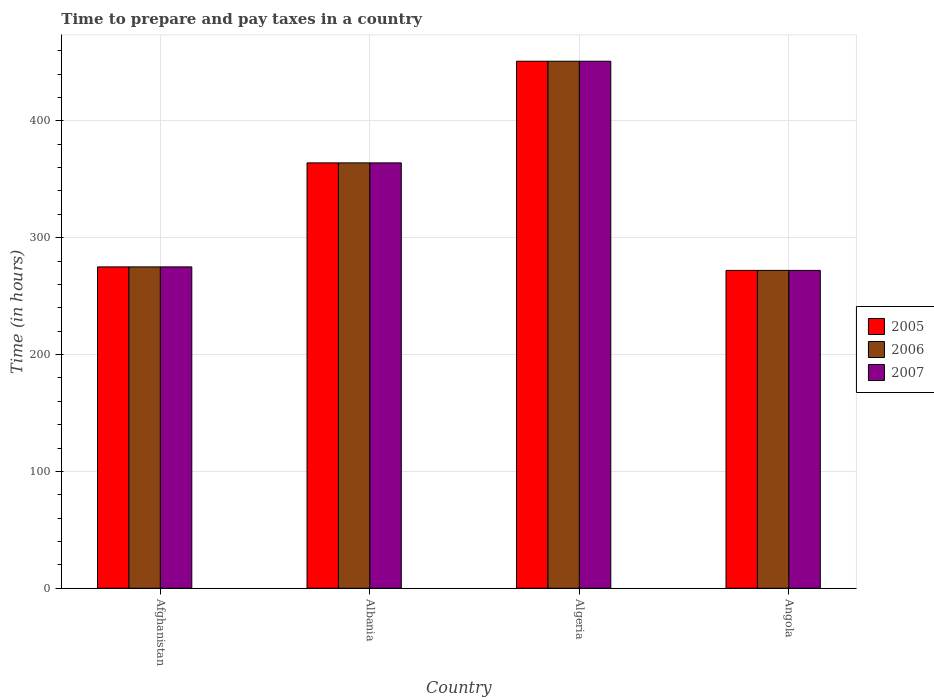How many groups of bars are there?
Ensure brevity in your answer.  4. Are the number of bars on each tick of the X-axis equal?
Offer a very short reply. Yes. How many bars are there on the 1st tick from the right?
Provide a succinct answer. 3. What is the label of the 3rd group of bars from the left?
Keep it short and to the point. Algeria. In how many cases, is the number of bars for a given country not equal to the number of legend labels?
Your answer should be very brief. 0. What is the number of hours required to prepare and pay taxes in 2007 in Albania?
Your response must be concise. 364. Across all countries, what is the maximum number of hours required to prepare and pay taxes in 2005?
Provide a succinct answer. 451. Across all countries, what is the minimum number of hours required to prepare and pay taxes in 2006?
Provide a short and direct response. 272. In which country was the number of hours required to prepare and pay taxes in 2006 maximum?
Offer a very short reply. Algeria. In which country was the number of hours required to prepare and pay taxes in 2007 minimum?
Make the answer very short. Angola. What is the total number of hours required to prepare and pay taxes in 2006 in the graph?
Provide a succinct answer. 1362. What is the difference between the number of hours required to prepare and pay taxes in 2006 in Albania and that in Angola?
Provide a short and direct response. 92. What is the difference between the number of hours required to prepare and pay taxes in 2007 in Angola and the number of hours required to prepare and pay taxes in 2005 in Albania?
Keep it short and to the point. -92. What is the average number of hours required to prepare and pay taxes in 2006 per country?
Your answer should be compact. 340.5. In how many countries, is the number of hours required to prepare and pay taxes in 2007 greater than 440 hours?
Keep it short and to the point. 1. What is the ratio of the number of hours required to prepare and pay taxes in 2006 in Albania to that in Angola?
Your answer should be very brief. 1.34. Is the difference between the number of hours required to prepare and pay taxes in 2007 in Afghanistan and Angola greater than the difference between the number of hours required to prepare and pay taxes in 2006 in Afghanistan and Angola?
Give a very brief answer. No. What is the difference between the highest and the second highest number of hours required to prepare and pay taxes in 2005?
Offer a terse response. -176. What is the difference between the highest and the lowest number of hours required to prepare and pay taxes in 2007?
Your answer should be very brief. 179. Is the sum of the number of hours required to prepare and pay taxes in 2005 in Afghanistan and Albania greater than the maximum number of hours required to prepare and pay taxes in 2007 across all countries?
Ensure brevity in your answer.  Yes. How many bars are there?
Offer a very short reply. 12. Are all the bars in the graph horizontal?
Keep it short and to the point. No. Are the values on the major ticks of Y-axis written in scientific E-notation?
Give a very brief answer. No. How many legend labels are there?
Your response must be concise. 3. What is the title of the graph?
Your answer should be very brief. Time to prepare and pay taxes in a country. Does "1991" appear as one of the legend labels in the graph?
Give a very brief answer. No. What is the label or title of the Y-axis?
Ensure brevity in your answer.  Time (in hours). What is the Time (in hours) in 2005 in Afghanistan?
Give a very brief answer. 275. What is the Time (in hours) of 2006 in Afghanistan?
Keep it short and to the point. 275. What is the Time (in hours) of 2007 in Afghanistan?
Your response must be concise. 275. What is the Time (in hours) of 2005 in Albania?
Your response must be concise. 364. What is the Time (in hours) in 2006 in Albania?
Keep it short and to the point. 364. What is the Time (in hours) of 2007 in Albania?
Provide a succinct answer. 364. What is the Time (in hours) in 2005 in Algeria?
Keep it short and to the point. 451. What is the Time (in hours) of 2006 in Algeria?
Your answer should be very brief. 451. What is the Time (in hours) in 2007 in Algeria?
Your answer should be compact. 451. What is the Time (in hours) in 2005 in Angola?
Give a very brief answer. 272. What is the Time (in hours) in 2006 in Angola?
Provide a short and direct response. 272. What is the Time (in hours) in 2007 in Angola?
Your answer should be compact. 272. Across all countries, what is the maximum Time (in hours) of 2005?
Provide a short and direct response. 451. Across all countries, what is the maximum Time (in hours) in 2006?
Provide a succinct answer. 451. Across all countries, what is the maximum Time (in hours) of 2007?
Provide a succinct answer. 451. Across all countries, what is the minimum Time (in hours) of 2005?
Offer a terse response. 272. Across all countries, what is the minimum Time (in hours) in 2006?
Ensure brevity in your answer.  272. Across all countries, what is the minimum Time (in hours) of 2007?
Keep it short and to the point. 272. What is the total Time (in hours) of 2005 in the graph?
Offer a terse response. 1362. What is the total Time (in hours) in 2006 in the graph?
Ensure brevity in your answer.  1362. What is the total Time (in hours) in 2007 in the graph?
Ensure brevity in your answer.  1362. What is the difference between the Time (in hours) of 2005 in Afghanistan and that in Albania?
Provide a succinct answer. -89. What is the difference between the Time (in hours) in 2006 in Afghanistan and that in Albania?
Provide a short and direct response. -89. What is the difference between the Time (in hours) in 2007 in Afghanistan and that in Albania?
Provide a short and direct response. -89. What is the difference between the Time (in hours) in 2005 in Afghanistan and that in Algeria?
Your answer should be compact. -176. What is the difference between the Time (in hours) in 2006 in Afghanistan and that in Algeria?
Provide a succinct answer. -176. What is the difference between the Time (in hours) of 2007 in Afghanistan and that in Algeria?
Keep it short and to the point. -176. What is the difference between the Time (in hours) of 2006 in Afghanistan and that in Angola?
Offer a very short reply. 3. What is the difference between the Time (in hours) of 2005 in Albania and that in Algeria?
Make the answer very short. -87. What is the difference between the Time (in hours) in 2006 in Albania and that in Algeria?
Ensure brevity in your answer.  -87. What is the difference between the Time (in hours) of 2007 in Albania and that in Algeria?
Your response must be concise. -87. What is the difference between the Time (in hours) in 2005 in Albania and that in Angola?
Offer a very short reply. 92. What is the difference between the Time (in hours) of 2006 in Albania and that in Angola?
Give a very brief answer. 92. What is the difference between the Time (in hours) of 2007 in Albania and that in Angola?
Your answer should be very brief. 92. What is the difference between the Time (in hours) of 2005 in Algeria and that in Angola?
Provide a succinct answer. 179. What is the difference between the Time (in hours) in 2006 in Algeria and that in Angola?
Ensure brevity in your answer.  179. What is the difference between the Time (in hours) in 2007 in Algeria and that in Angola?
Provide a succinct answer. 179. What is the difference between the Time (in hours) of 2005 in Afghanistan and the Time (in hours) of 2006 in Albania?
Keep it short and to the point. -89. What is the difference between the Time (in hours) in 2005 in Afghanistan and the Time (in hours) in 2007 in Albania?
Your response must be concise. -89. What is the difference between the Time (in hours) in 2006 in Afghanistan and the Time (in hours) in 2007 in Albania?
Provide a succinct answer. -89. What is the difference between the Time (in hours) of 2005 in Afghanistan and the Time (in hours) of 2006 in Algeria?
Ensure brevity in your answer.  -176. What is the difference between the Time (in hours) in 2005 in Afghanistan and the Time (in hours) in 2007 in Algeria?
Your answer should be compact. -176. What is the difference between the Time (in hours) of 2006 in Afghanistan and the Time (in hours) of 2007 in Algeria?
Offer a terse response. -176. What is the difference between the Time (in hours) in 2006 in Afghanistan and the Time (in hours) in 2007 in Angola?
Offer a terse response. 3. What is the difference between the Time (in hours) in 2005 in Albania and the Time (in hours) in 2006 in Algeria?
Your response must be concise. -87. What is the difference between the Time (in hours) of 2005 in Albania and the Time (in hours) of 2007 in Algeria?
Provide a succinct answer. -87. What is the difference between the Time (in hours) in 2006 in Albania and the Time (in hours) in 2007 in Algeria?
Give a very brief answer. -87. What is the difference between the Time (in hours) in 2005 in Albania and the Time (in hours) in 2006 in Angola?
Ensure brevity in your answer.  92. What is the difference between the Time (in hours) in 2005 in Albania and the Time (in hours) in 2007 in Angola?
Your response must be concise. 92. What is the difference between the Time (in hours) of 2006 in Albania and the Time (in hours) of 2007 in Angola?
Make the answer very short. 92. What is the difference between the Time (in hours) in 2005 in Algeria and the Time (in hours) in 2006 in Angola?
Offer a terse response. 179. What is the difference between the Time (in hours) in 2005 in Algeria and the Time (in hours) in 2007 in Angola?
Make the answer very short. 179. What is the difference between the Time (in hours) of 2006 in Algeria and the Time (in hours) of 2007 in Angola?
Ensure brevity in your answer.  179. What is the average Time (in hours) in 2005 per country?
Ensure brevity in your answer.  340.5. What is the average Time (in hours) of 2006 per country?
Offer a very short reply. 340.5. What is the average Time (in hours) of 2007 per country?
Your answer should be very brief. 340.5. What is the difference between the Time (in hours) in 2005 and Time (in hours) in 2007 in Afghanistan?
Your response must be concise. 0. What is the difference between the Time (in hours) of 2006 and Time (in hours) of 2007 in Afghanistan?
Your answer should be compact. 0. What is the difference between the Time (in hours) of 2006 and Time (in hours) of 2007 in Albania?
Offer a terse response. 0. What is the difference between the Time (in hours) of 2005 and Time (in hours) of 2006 in Algeria?
Your answer should be compact. 0. What is the difference between the Time (in hours) in 2006 and Time (in hours) in 2007 in Algeria?
Give a very brief answer. 0. What is the difference between the Time (in hours) of 2005 and Time (in hours) of 2006 in Angola?
Provide a short and direct response. 0. What is the difference between the Time (in hours) of 2005 and Time (in hours) of 2007 in Angola?
Your response must be concise. 0. What is the difference between the Time (in hours) in 2006 and Time (in hours) in 2007 in Angola?
Provide a succinct answer. 0. What is the ratio of the Time (in hours) of 2005 in Afghanistan to that in Albania?
Your response must be concise. 0.76. What is the ratio of the Time (in hours) of 2006 in Afghanistan to that in Albania?
Your answer should be very brief. 0.76. What is the ratio of the Time (in hours) in 2007 in Afghanistan to that in Albania?
Provide a succinct answer. 0.76. What is the ratio of the Time (in hours) in 2005 in Afghanistan to that in Algeria?
Keep it short and to the point. 0.61. What is the ratio of the Time (in hours) of 2006 in Afghanistan to that in Algeria?
Your response must be concise. 0.61. What is the ratio of the Time (in hours) of 2007 in Afghanistan to that in Algeria?
Make the answer very short. 0.61. What is the ratio of the Time (in hours) in 2005 in Afghanistan to that in Angola?
Keep it short and to the point. 1.01. What is the ratio of the Time (in hours) in 2007 in Afghanistan to that in Angola?
Give a very brief answer. 1.01. What is the ratio of the Time (in hours) of 2005 in Albania to that in Algeria?
Provide a short and direct response. 0.81. What is the ratio of the Time (in hours) of 2006 in Albania to that in Algeria?
Your answer should be compact. 0.81. What is the ratio of the Time (in hours) in 2007 in Albania to that in Algeria?
Offer a very short reply. 0.81. What is the ratio of the Time (in hours) in 2005 in Albania to that in Angola?
Keep it short and to the point. 1.34. What is the ratio of the Time (in hours) in 2006 in Albania to that in Angola?
Your response must be concise. 1.34. What is the ratio of the Time (in hours) of 2007 in Albania to that in Angola?
Keep it short and to the point. 1.34. What is the ratio of the Time (in hours) of 2005 in Algeria to that in Angola?
Ensure brevity in your answer.  1.66. What is the ratio of the Time (in hours) of 2006 in Algeria to that in Angola?
Keep it short and to the point. 1.66. What is the ratio of the Time (in hours) of 2007 in Algeria to that in Angola?
Offer a very short reply. 1.66. What is the difference between the highest and the second highest Time (in hours) of 2006?
Your answer should be very brief. 87. What is the difference between the highest and the lowest Time (in hours) in 2005?
Ensure brevity in your answer.  179. What is the difference between the highest and the lowest Time (in hours) of 2006?
Provide a succinct answer. 179. What is the difference between the highest and the lowest Time (in hours) in 2007?
Offer a terse response. 179. 